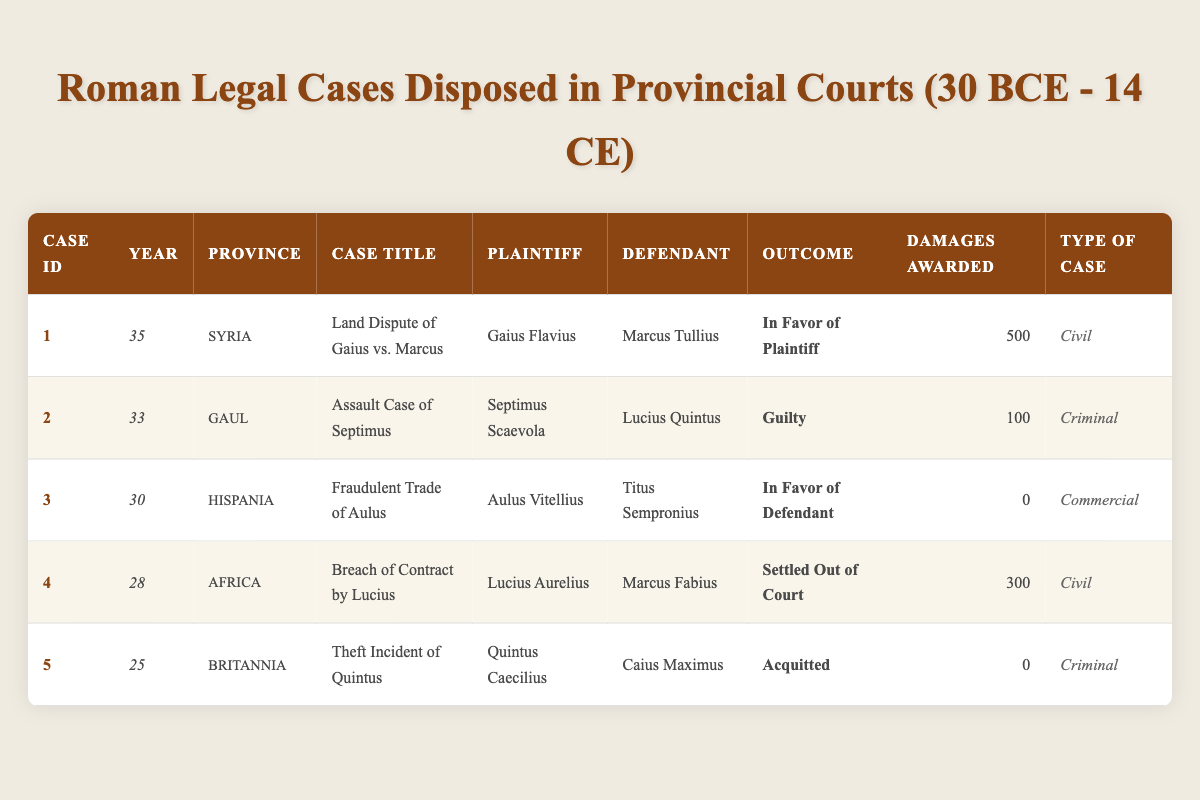What was the most recent case recorded in the table? The most recent year present in the table is 35. Looking through the entries, the only case from that year is "Land Dispute of Gaius vs. Marcus."
Answer: Land Dispute of Gaius vs. Marcus How many cases resulted in a verdict of "In Favor of Defendant"? There is one case in the table with the outcome "In Favor of Defendant," which is "Fraudulent Trade of Aulus" from the year 30.
Answer: 1 Which province had the highest damages awarded in a case? Examining the damages, Syria has the highest award of 500 for the case "Land Dispute of Gaius vs. Marcus." Other cases have lower amounts.
Answer: Syria Was there any case settled out of court? The entry for "Breach of Contract by Lucius" notes it was "Settled Out of Court." Hence, there is at least one case settled this way in the table.
Answer: Yes What is the total amount of damages awarded across all cases? By summing the damages awarded in each case: 500 (Syria) + 100 (Gaul) + 0 (Hispania) + 300 (Africa) + 0 (Britannia) = 900.
Answer: 900 In which province was the "Assault Case of Septimus" held? The table shows this case was tried in the province of Gaul.
Answer: Gaul How many cases were categorized as criminal? There are two cases labeled as criminal: "Assault Case of Septimus" and "Theft Incident of Quintus" in the table.
Answer: 2 What was the outcome of cases in the province of Africa? The outcome in Africa was "Settled Out of Court" for the case "Breach of Contract by Lucius."
Answer: Settled Out of Court Which type of case had no damages awarded? Both "Fraudulent Trade of Aulus" and "Theft Incident of Quintus" are the cases with damages awarded of 0, where one is commercial and the other is criminal. Therefore, there are two types without damages.
Answer: Commercial and Criminal 